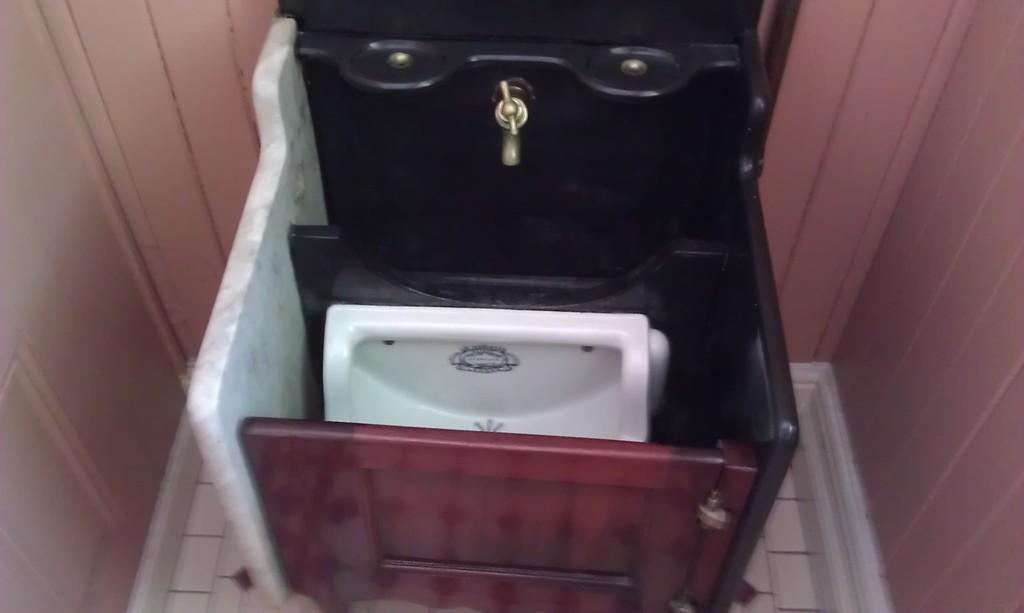What color is the toilet seat in the image? The toilet seat in the image is white. What can be used for washing hands in the image? There is a tap in the image that can be used for washing hands. What type of material is the wooden object in the image made of? The wooden object in the image is made of wood. Can you describe any other objects present in the image? There are other objects in the image, but their specific details are not mentioned in the provided facts. Is there a scarecrow in the image to protect the toilet seat from birds? No, there is no scarecrow present in the image. Can you see a nest built by birds on the wooden object in the image? No, there is no nest visible on the wooden object in the image. 